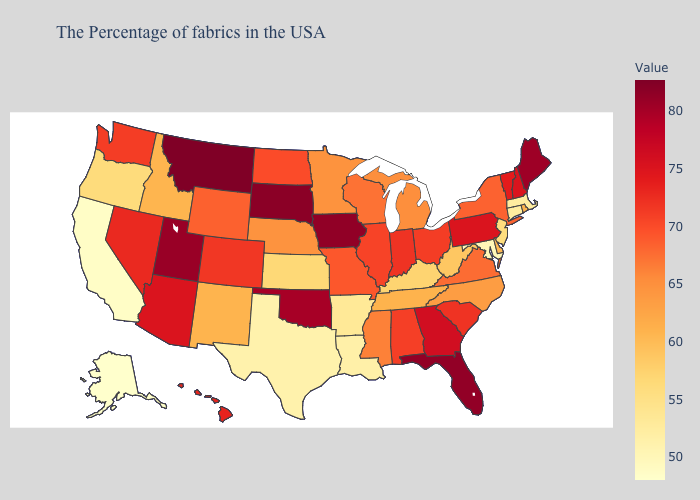Among the states that border Ohio , does Pennsylvania have the lowest value?
Short answer required. No. Among the states that border West Virginia , does Virginia have the highest value?
Quick response, please. No. Does the map have missing data?
Concise answer only. No. 